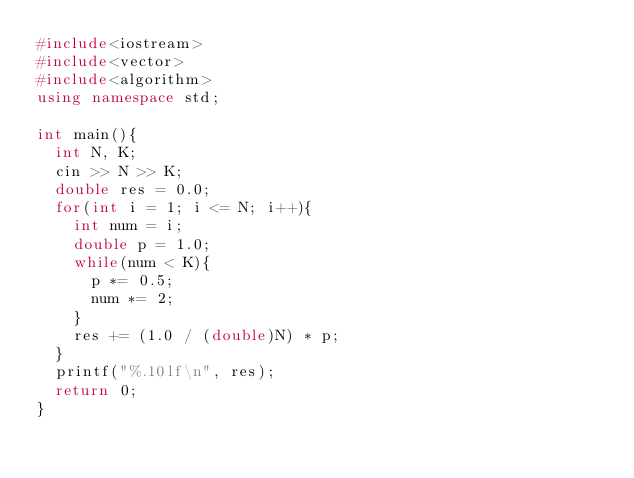<code> <loc_0><loc_0><loc_500><loc_500><_C++_>#include<iostream>
#include<vector>
#include<algorithm>
using namespace std;

int main(){
	int N, K;
	cin >> N >> K;
	double res = 0.0;
	for(int i = 1; i <= N; i++){
		int num = i;
		double p = 1.0;
		while(num < K){
			p *= 0.5;
			num *= 2;
		}
		res += (1.0 / (double)N) * p;
	}
	printf("%.10lf\n", res);
	return 0;
}
</code> 